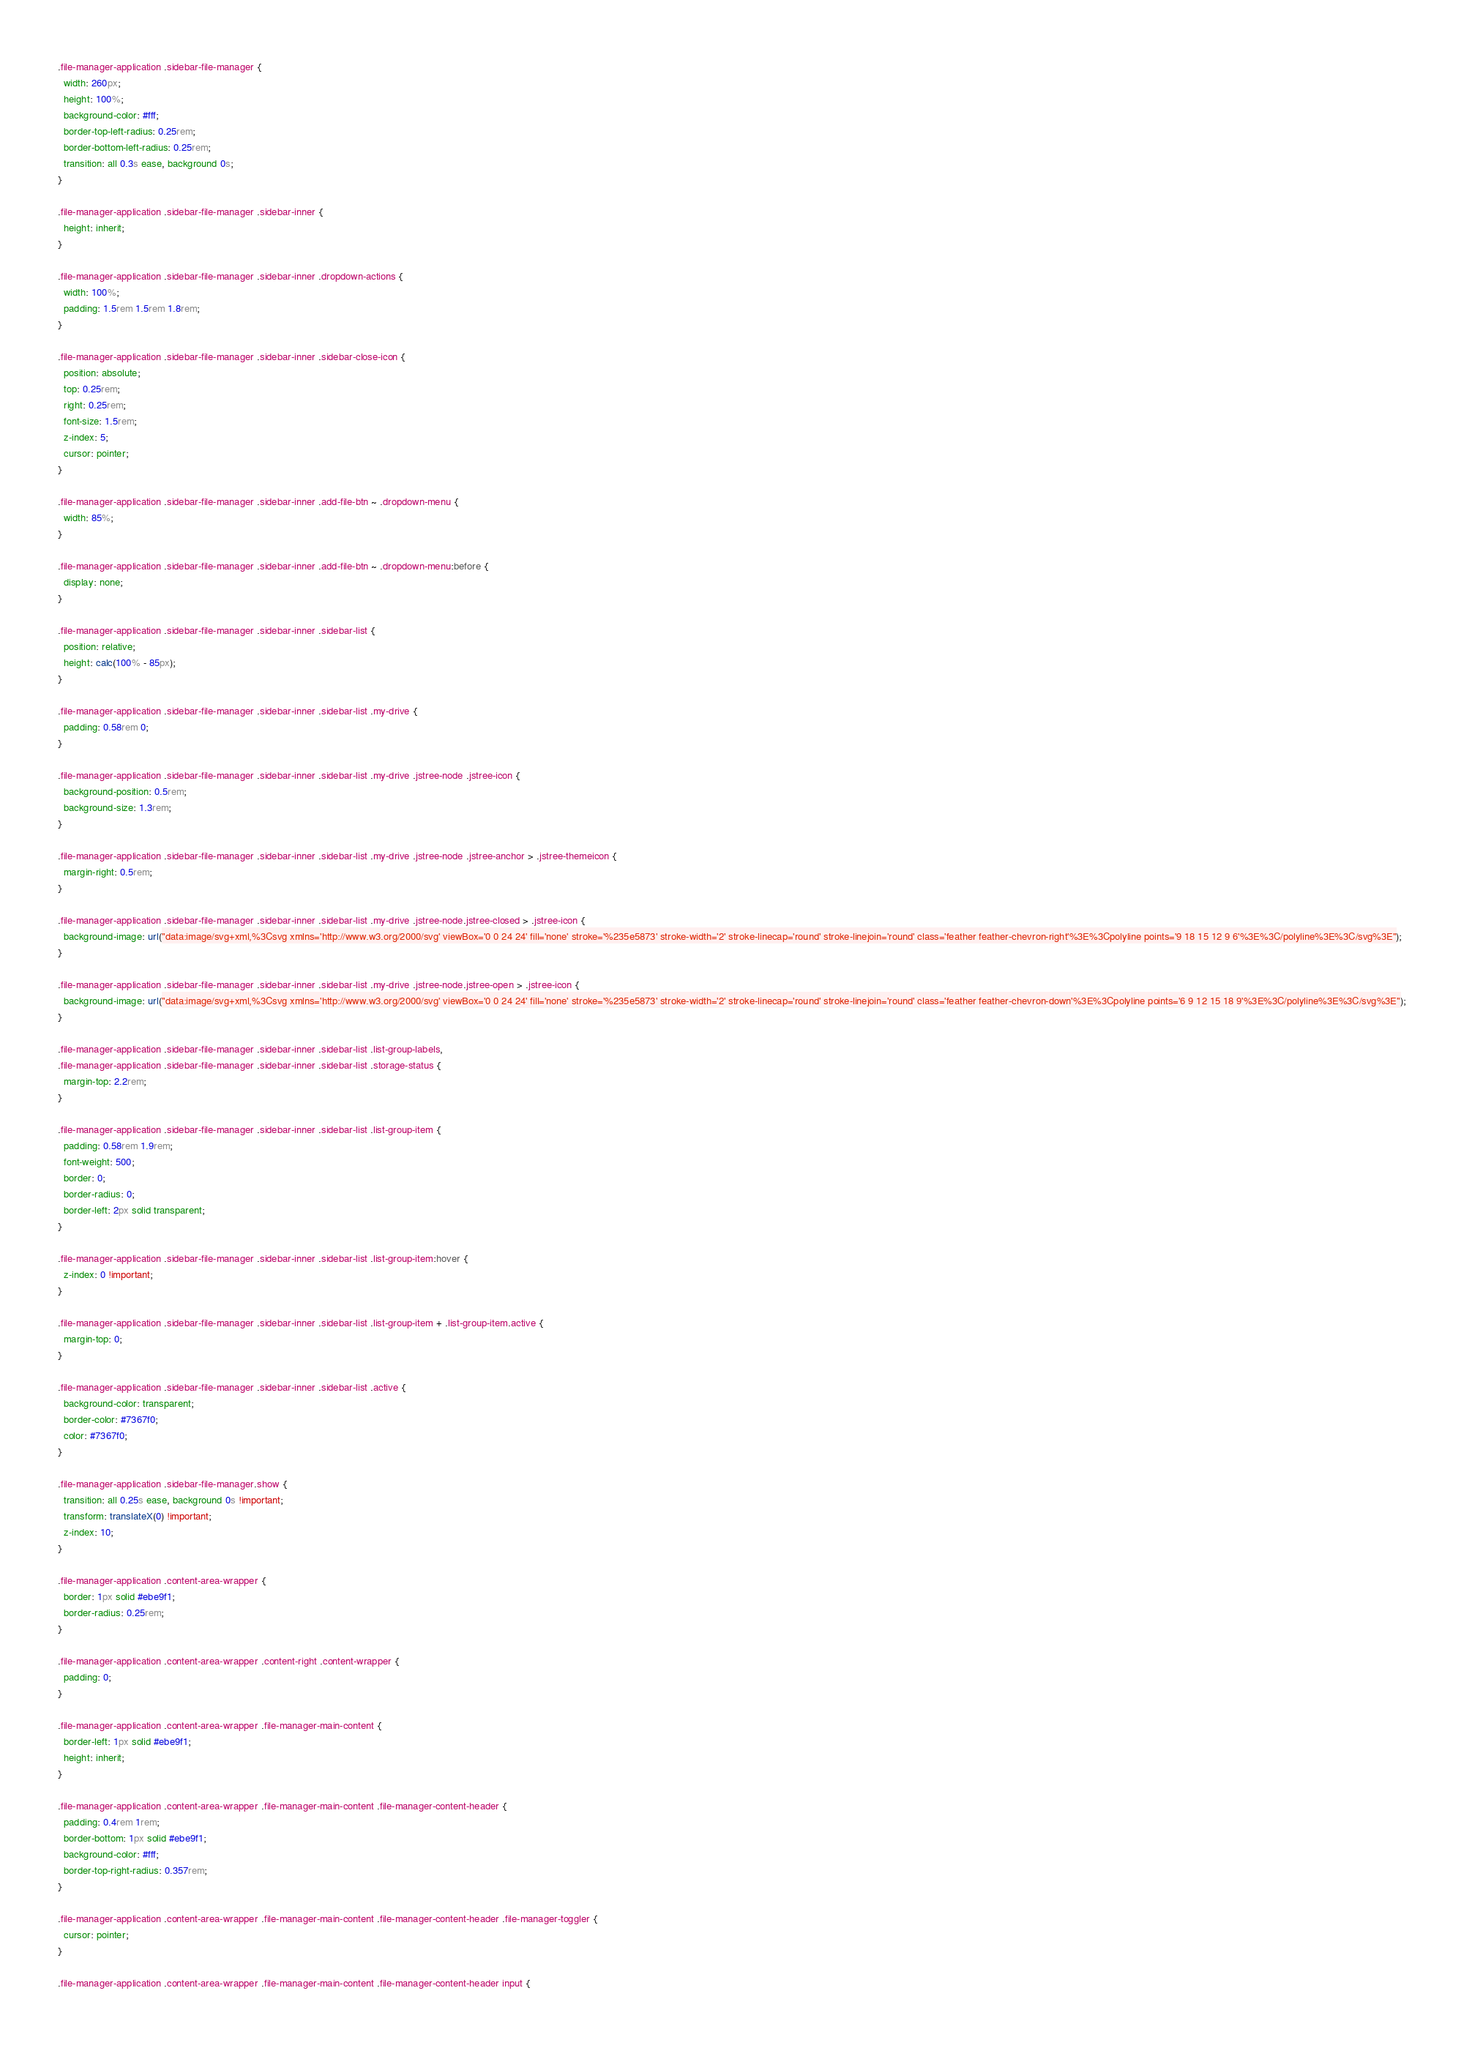<code> <loc_0><loc_0><loc_500><loc_500><_CSS_>.file-manager-application .sidebar-file-manager {
  width: 260px;
  height: 100%;
  background-color: #fff;
  border-top-left-radius: 0.25rem;
  border-bottom-left-radius: 0.25rem;
  transition: all 0.3s ease, background 0s;
}

.file-manager-application .sidebar-file-manager .sidebar-inner {
  height: inherit;
}

.file-manager-application .sidebar-file-manager .sidebar-inner .dropdown-actions {
  width: 100%;
  padding: 1.5rem 1.5rem 1.8rem;
}

.file-manager-application .sidebar-file-manager .sidebar-inner .sidebar-close-icon {
  position: absolute;
  top: 0.25rem;
  right: 0.25rem;
  font-size: 1.5rem;
  z-index: 5;
  cursor: pointer;
}

.file-manager-application .sidebar-file-manager .sidebar-inner .add-file-btn ~ .dropdown-menu {
  width: 85%;
}

.file-manager-application .sidebar-file-manager .sidebar-inner .add-file-btn ~ .dropdown-menu:before {
  display: none;
}

.file-manager-application .sidebar-file-manager .sidebar-inner .sidebar-list {
  position: relative;
  height: calc(100% - 85px);
}

.file-manager-application .sidebar-file-manager .sidebar-inner .sidebar-list .my-drive {
  padding: 0.58rem 0;
}

.file-manager-application .sidebar-file-manager .sidebar-inner .sidebar-list .my-drive .jstree-node .jstree-icon {
  background-position: 0.5rem;
  background-size: 1.3rem;
}

.file-manager-application .sidebar-file-manager .sidebar-inner .sidebar-list .my-drive .jstree-node .jstree-anchor > .jstree-themeicon {
  margin-right: 0.5rem;
}

.file-manager-application .sidebar-file-manager .sidebar-inner .sidebar-list .my-drive .jstree-node.jstree-closed > .jstree-icon {
  background-image: url("data:image/svg+xml,%3Csvg xmlns='http://www.w3.org/2000/svg' viewBox='0 0 24 24' fill='none' stroke='%235e5873' stroke-width='2' stroke-linecap='round' stroke-linejoin='round' class='feather feather-chevron-right'%3E%3Cpolyline points='9 18 15 12 9 6'%3E%3C/polyline%3E%3C/svg%3E");
}

.file-manager-application .sidebar-file-manager .sidebar-inner .sidebar-list .my-drive .jstree-node.jstree-open > .jstree-icon {
  background-image: url("data:image/svg+xml,%3Csvg xmlns='http://www.w3.org/2000/svg' viewBox='0 0 24 24' fill='none' stroke='%235e5873' stroke-width='2' stroke-linecap='round' stroke-linejoin='round' class='feather feather-chevron-down'%3E%3Cpolyline points='6 9 12 15 18 9'%3E%3C/polyline%3E%3C/svg%3E");
}

.file-manager-application .sidebar-file-manager .sidebar-inner .sidebar-list .list-group-labels,
.file-manager-application .sidebar-file-manager .sidebar-inner .sidebar-list .storage-status {
  margin-top: 2.2rem;
}

.file-manager-application .sidebar-file-manager .sidebar-inner .sidebar-list .list-group-item {
  padding: 0.58rem 1.9rem;
  font-weight: 500;
  border: 0;
  border-radius: 0;
  border-left: 2px solid transparent;
}

.file-manager-application .sidebar-file-manager .sidebar-inner .sidebar-list .list-group-item:hover {
  z-index: 0 !important;
}

.file-manager-application .sidebar-file-manager .sidebar-inner .sidebar-list .list-group-item + .list-group-item.active {
  margin-top: 0;
}

.file-manager-application .sidebar-file-manager .sidebar-inner .sidebar-list .active {
  background-color: transparent;
  border-color: #7367f0;
  color: #7367f0;
}

.file-manager-application .sidebar-file-manager.show {
  transition: all 0.25s ease, background 0s !important;
  transform: translateX(0) !important;
  z-index: 10;
}

.file-manager-application .content-area-wrapper {
  border: 1px solid #ebe9f1;
  border-radius: 0.25rem;
}

.file-manager-application .content-area-wrapper .content-right .content-wrapper {
  padding: 0;
}

.file-manager-application .content-area-wrapper .file-manager-main-content {
  border-left: 1px solid #ebe9f1;
  height: inherit;
}

.file-manager-application .content-area-wrapper .file-manager-main-content .file-manager-content-header {
  padding: 0.4rem 1rem;
  border-bottom: 1px solid #ebe9f1;
  background-color: #fff;
  border-top-right-radius: 0.357rem;
}

.file-manager-application .content-area-wrapper .file-manager-main-content .file-manager-content-header .file-manager-toggler {
  cursor: pointer;
}

.file-manager-application .content-area-wrapper .file-manager-main-content .file-manager-content-header input {</code> 